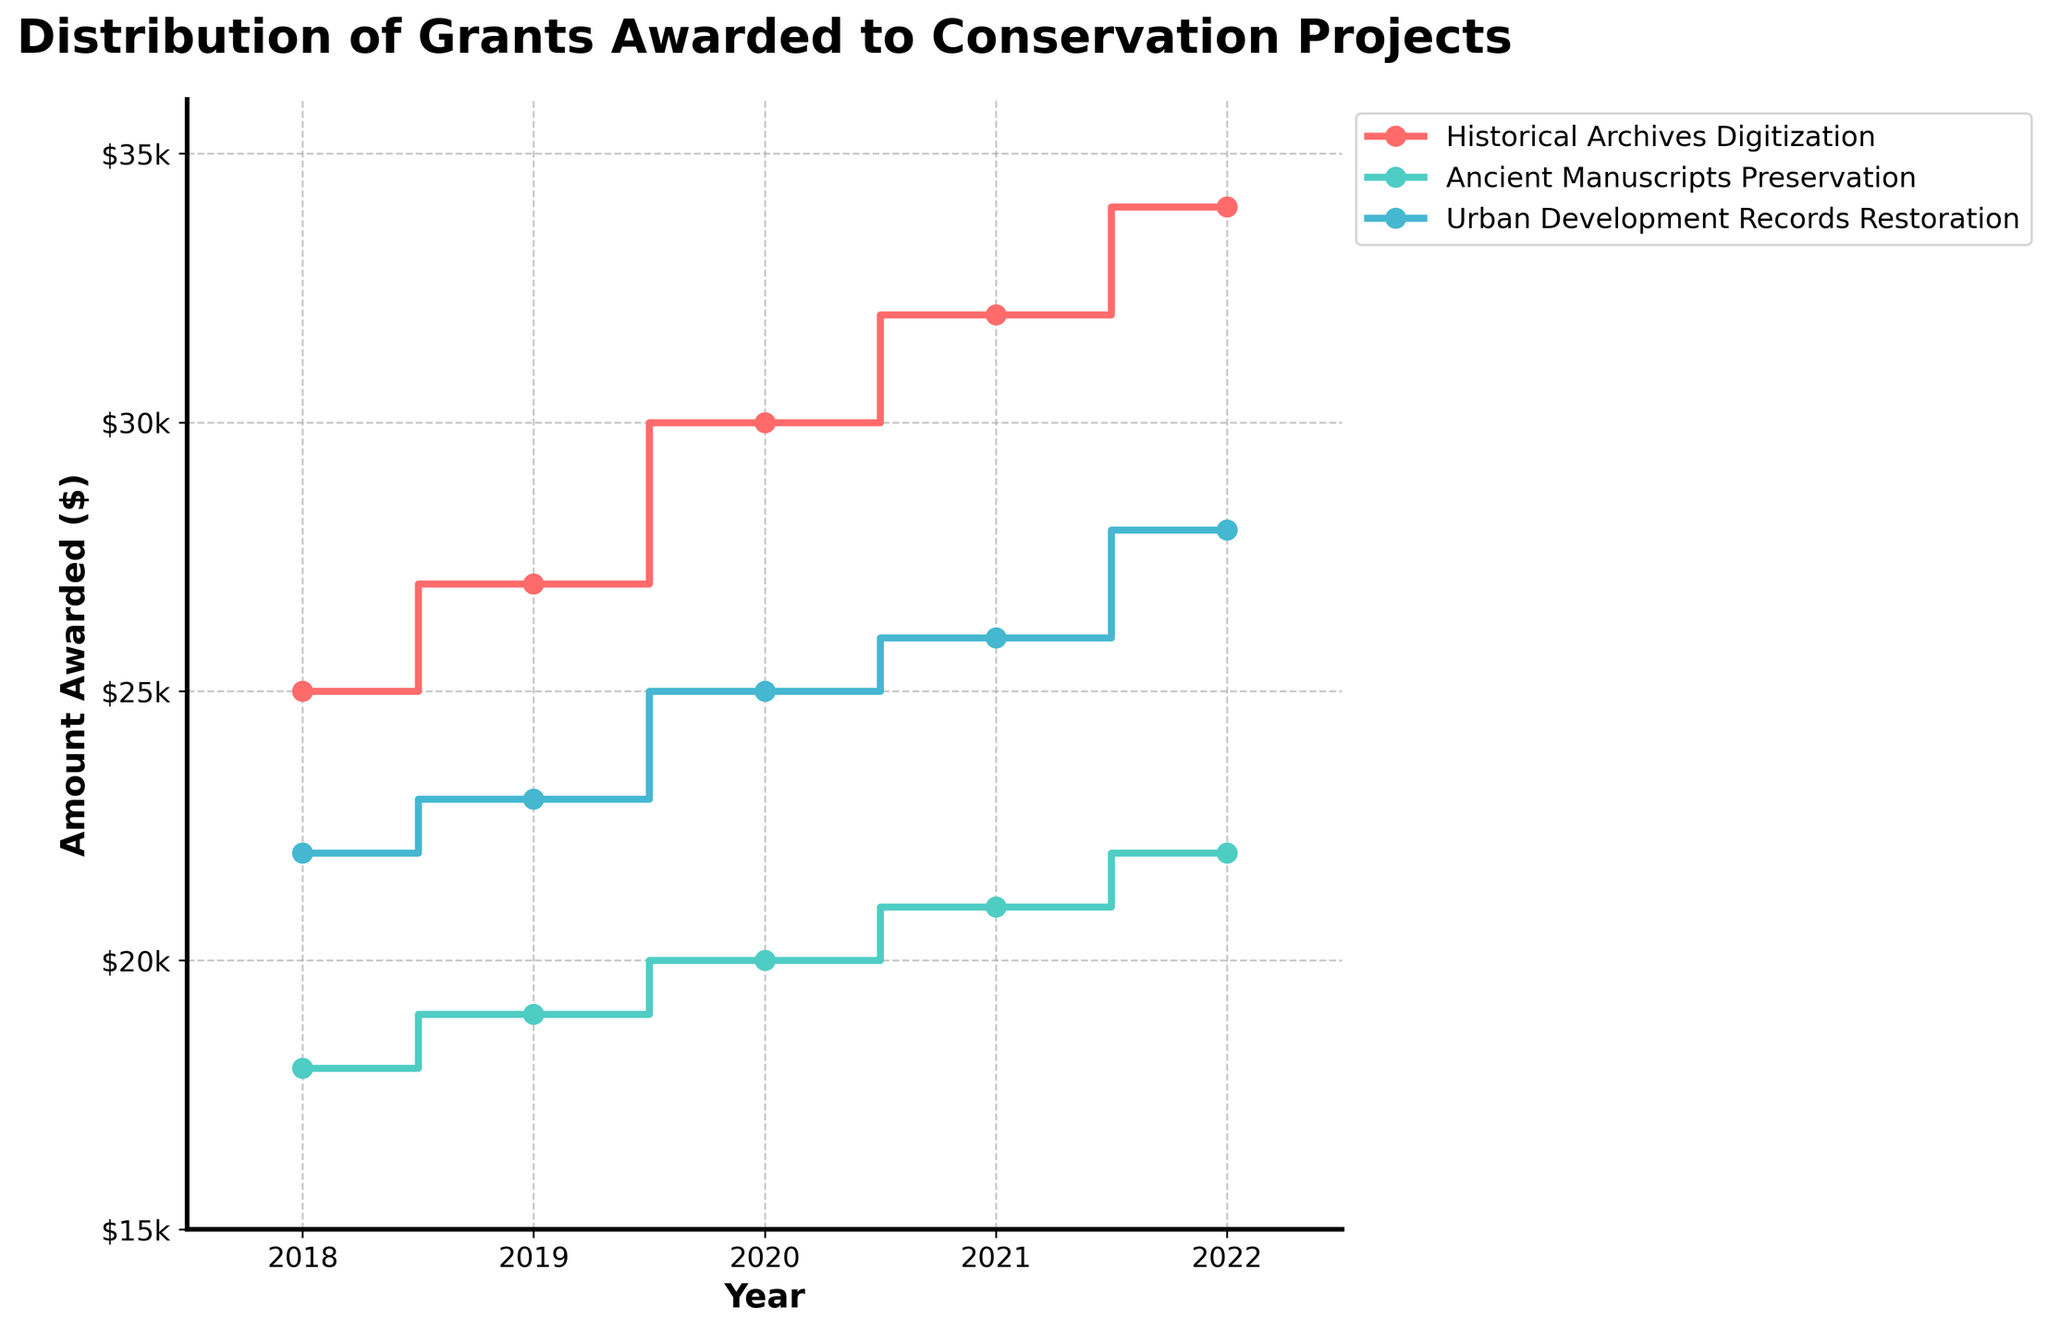What's the title of the figure? The title of the figure is usually located at the top of the figure.
Answer: Distribution of Grants Awarded to Conservation Projects Which project was awarded the most grants consistently over the five years? By observing the stair plot with different colored lines, we can see that the purple line (representing Historical Archives Digitization) consistently has the highest values across all years.
Answer: Historical Archives Digitization How much was awarded to the Ancient Manuscripts Preservation project in 2020? Locate the specific color and line for the Ancient Manuscripts Preservation project and trace it to the year 2020; match it to the y-axis value.
Answer: 20,000 What is the total amount awarded to the Urban Development Records Restoration project over the five years? Sum up the awarded amounts for Urban Development Records Restoration from 2018 to 2022. 22,000 + 23,000 + 25,000 + 26,000 + 28,000.
Answer: 124,000 Between which two consecutive years did the Historical Archives Digitization project see the greatest increase in grants awarded? Analyze the steps in the stair line for Historical Archives Digitization and identify the largest vertical jump (difference in grant amounts).
Answer: 2020 to 2021 Comparing the year 2018, which project received the least amount of grants? Compare the heights of the steps for all projects in the year 2018, and identify the shortest one.
Answer: Ancient Manuscripts Preservation What is the average amount awarded per year to the Historical Archives Digitization project over the five years? Calculate the average by summing the amounts awarded each year from 2018 to 2022 for the Historical Archives Digitization project (25,000 + 27,000 + 30,000 + 32,000 + 34,000) and dividing by the number of years (5).
Answer: 29,600 Considering the trend over the years, which project shows the most steadily increasing grant amounts? Compare the overall trends in the step lines for each project. The line with a consistent upward slope is the most steadily increasing.
Answer: Historical Archives Digitization Which project had the smallest increase in funding from 2018 to 2019? Identify the y-values for all projects in 2018 and 2019, then calculate the difference for each project and find the smallest increment.
Answer: Ancient Manuscripts Preservation How much more was awarded to the Historical Archives Digitization project than the Urban Development Records Restoration project in 2022? Subtract the amount awarded to Urban Development Records Restoration (28,000) from the amount awarded to Historical Archives Digitization (34,000) in 2022.
Answer: 6,000 